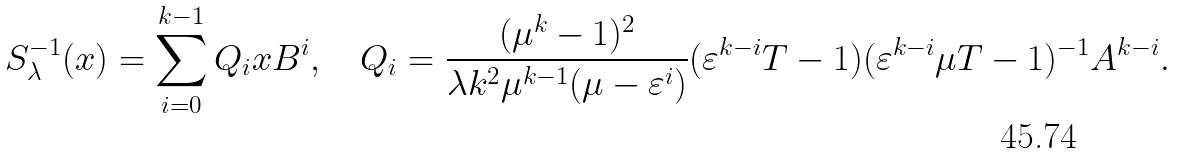Convert formula to latex. <formula><loc_0><loc_0><loc_500><loc_500>S _ { \lambda } ^ { - 1 } ( x ) = \sum _ { i = 0 } ^ { k - 1 } Q _ { i } x B ^ { i } , \quad Q _ { i } = \frac { ( \mu ^ { k } - 1 ) ^ { 2 } } { \lambda k ^ { 2 } \mu ^ { k - 1 } ( \mu - \varepsilon ^ { i } ) } ( \varepsilon ^ { k - i } T - { 1 } ) ( \varepsilon ^ { k - i } \mu T - { 1 } ) ^ { - 1 } A ^ { k - i } .</formula> 